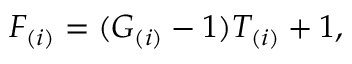<formula> <loc_0><loc_0><loc_500><loc_500>F _ { ( i ) } = ( G _ { ( i ) } - 1 ) T _ { ( i ) } + 1 ,</formula> 